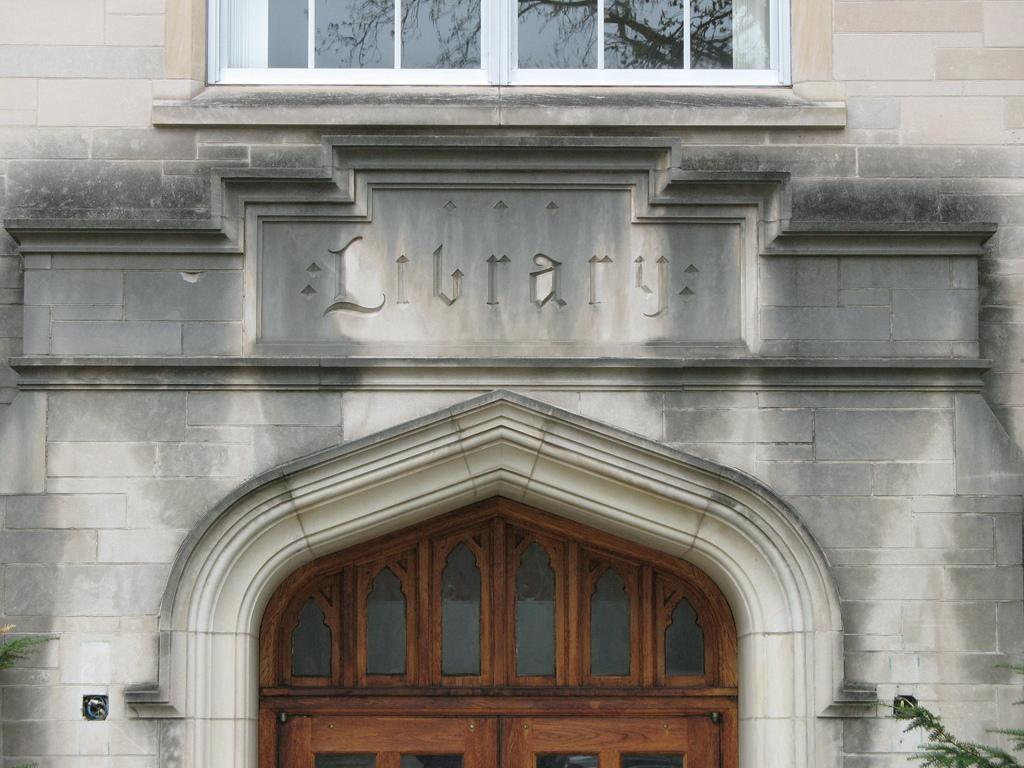Can you describe this image briefly? In this image we can see a building, window and a door. We can see leaves in the right bottom of the image and on the left side of the image. 